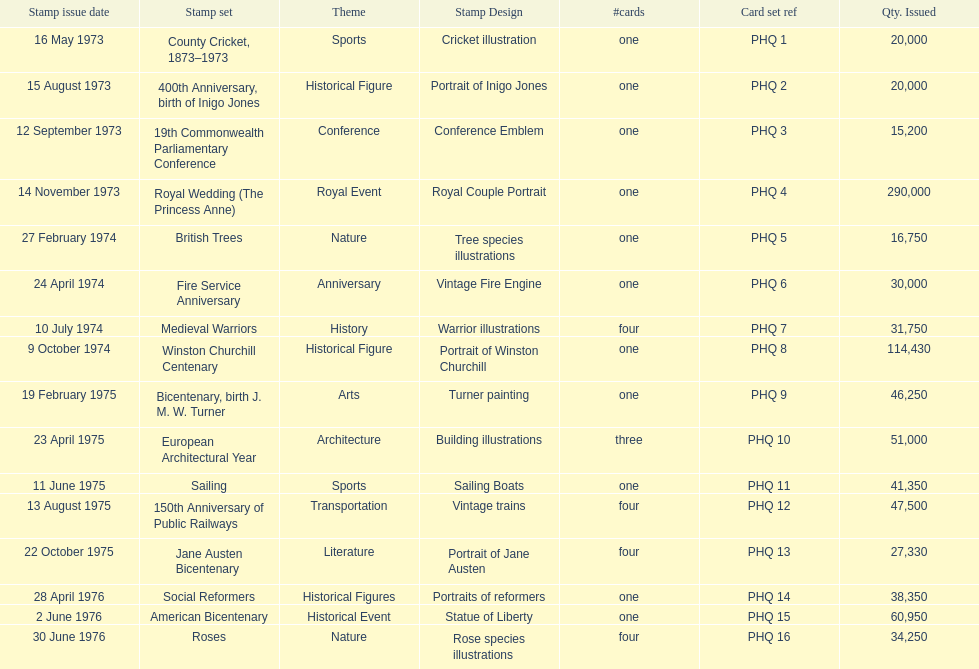How many stamp sets had at least 50,000 issued? 4. 